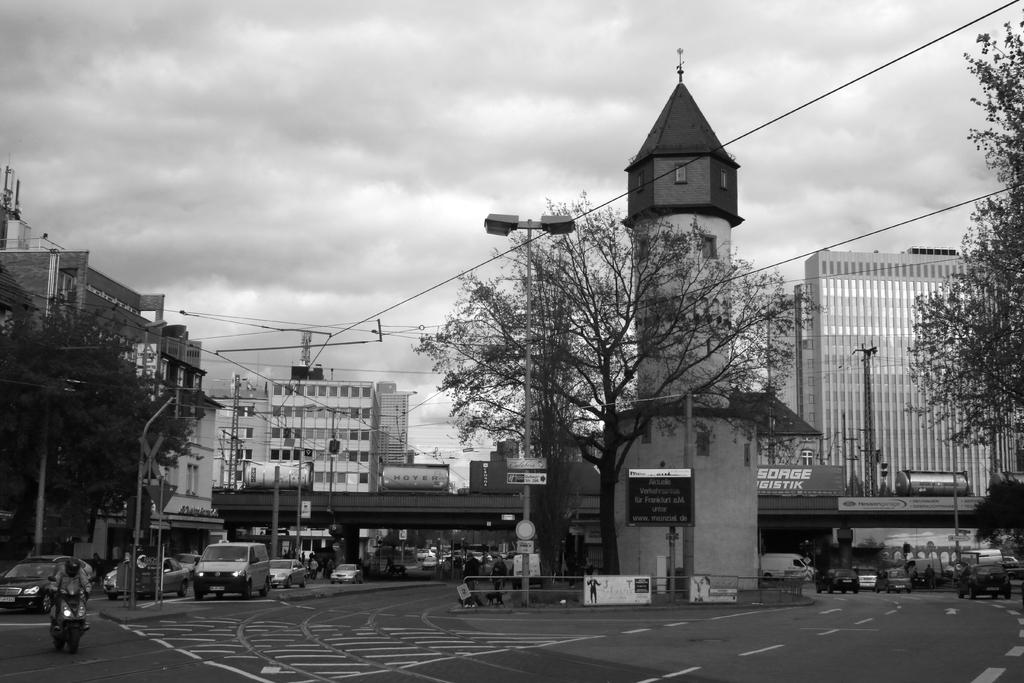What can be seen on the road in the image? There are vehicles on the road in the image. What is the tall structure with a light on top in the image? There is a light pole in the image. What type of vegetation is present in the image? There are trees in the image. What type of man-made structures are visible in the image? There are buildings in the image. What part of the natural environment is visible in the image? The sky is visible in the image. What type of pen can be seen falling from the sky in the image? There is no pen falling from the sky in the image; it is in black and white and does not depict any falling objects. What type of brick is used to construct the buildings in the image? The image is in black and white, so it is not possible to determine the type of brick used to construct the buildings. 